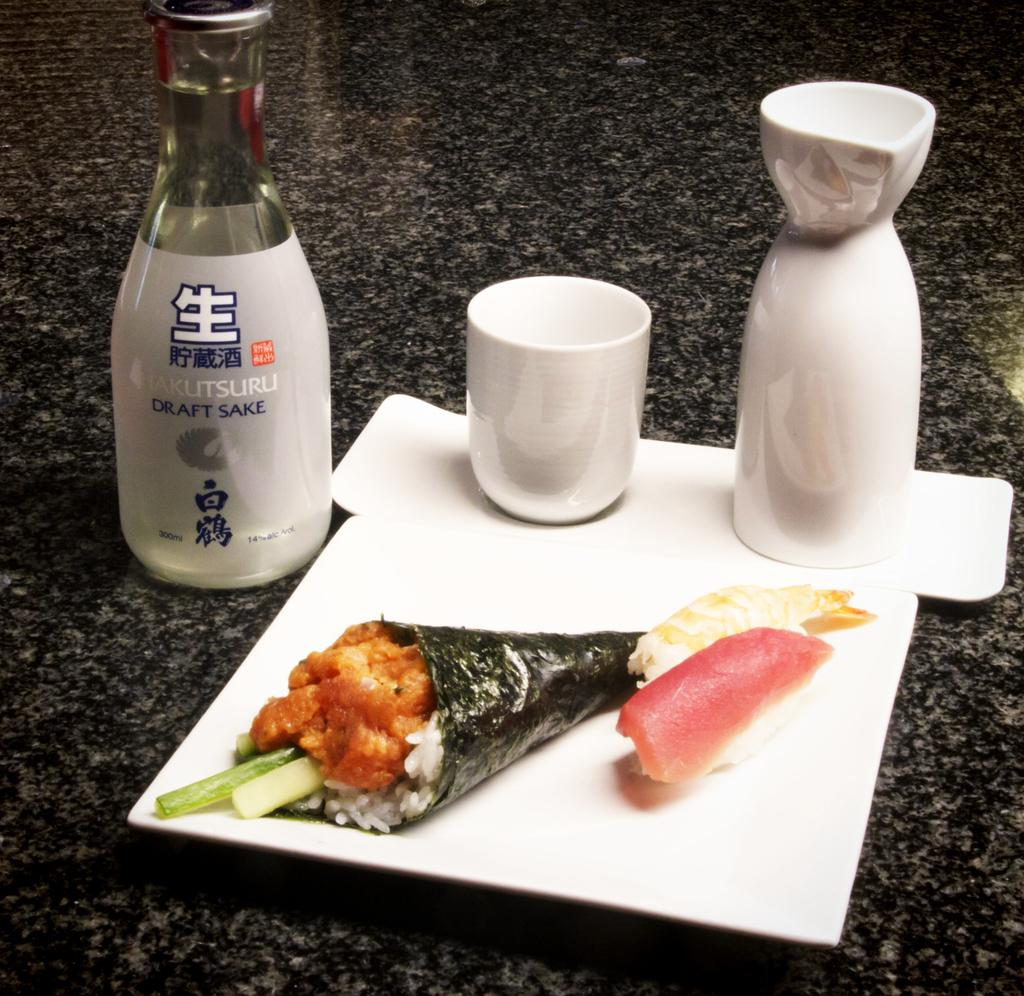What piece of furniture is present in the image? There is a table in the image. What objects are placed on the table? There are bottles, a cup, and food items on the table. Can you describe the type of containers on the table? The containers on the table are bottles and a cup. What might be used for consuming the food items on the table? The cup on the table might be used for consuming a beverage. What type of lettuce can be seen growing on the back of the table in the image? There is no lettuce present in the image, and the table does not have a back. 